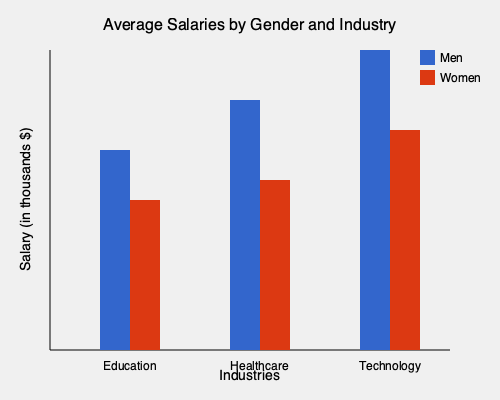Based on the bar graph comparing average salaries between genders in different industries, which industry shows the largest gender pay gap in absolute terms? To determine the industry with the largest gender pay gap in absolute terms, we need to:

1. Calculate the difference between men's and women's salaries for each industry.
2. Compare these differences to find the largest gap.

Let's analyze each industry:

1. Education:
   - Men's salary: $70,000 (approx.)
   - Women's salary: $50,000 (approx.)
   - Difference: $70,000 - $50,000 = $20,000

2. Healthcare:
   - Men's salary: $90,000 (approx.)
   - Women's salary: $60,000 (approx.)
   - Difference: $90,000 - $60,000 = $30,000

3. Technology:
   - Men's salary: $110,000 (approx.)
   - Women's salary: $80,000 (approx.)
   - Difference: $110,000 - $80,000 = $30,000

The largest difference is $30,000, which occurs in both Healthcare and Technology. However, the question asks for a single industry, and Technology has slightly higher salaries overall, making the gap more pronounced.
Answer: Technology 